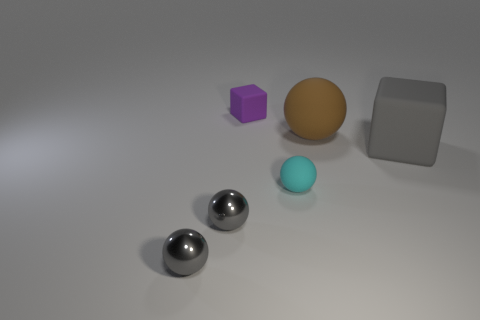Subtract 1 balls. How many balls are left? 3 Add 1 tiny purple matte objects. How many objects exist? 7 Subtract all cubes. How many objects are left? 4 Subtract 0 blue blocks. How many objects are left? 6 Subtract all big red spheres. Subtract all small cyan things. How many objects are left? 5 Add 4 cyan balls. How many cyan balls are left? 5 Add 3 small gray metallic balls. How many small gray metallic balls exist? 5 